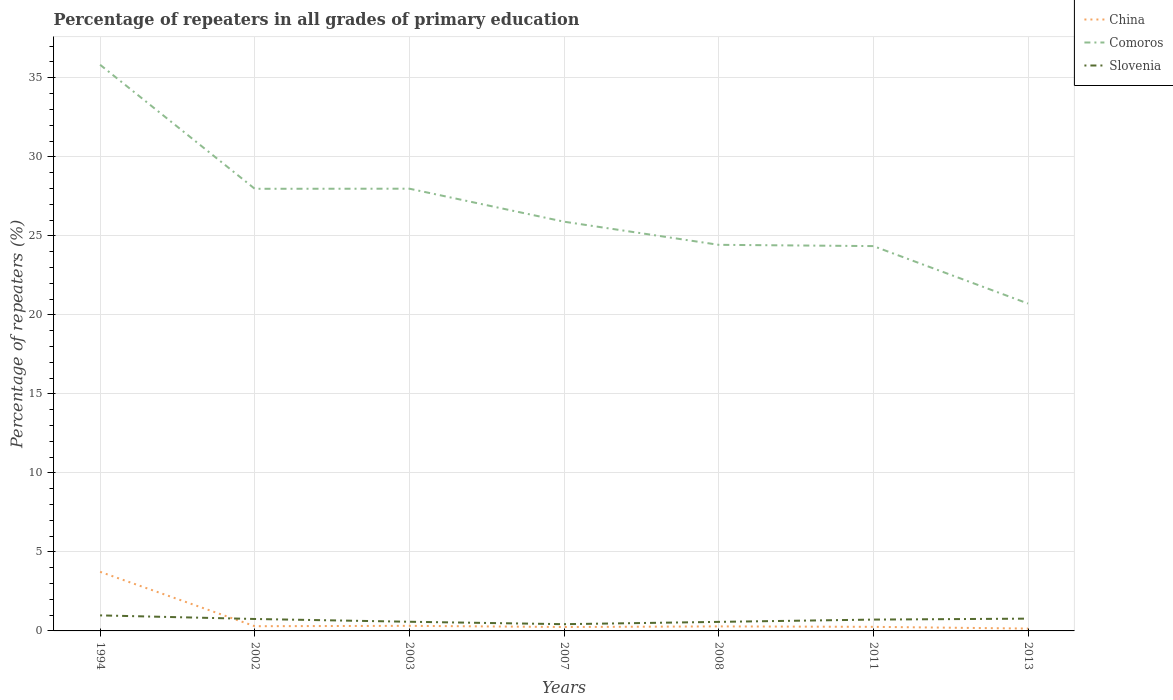How many different coloured lines are there?
Your answer should be compact. 3. Across all years, what is the maximum percentage of repeaters in Slovenia?
Ensure brevity in your answer.  0.43. What is the total percentage of repeaters in Slovenia in the graph?
Provide a short and direct response. 0.4. What is the difference between the highest and the second highest percentage of repeaters in Comoros?
Your answer should be very brief. 15.11. What is the difference between the highest and the lowest percentage of repeaters in China?
Keep it short and to the point. 1. Is the percentage of repeaters in Slovenia strictly greater than the percentage of repeaters in Comoros over the years?
Your answer should be very brief. Yes. How many lines are there?
Your response must be concise. 3. How many years are there in the graph?
Provide a short and direct response. 7. What is the difference between two consecutive major ticks on the Y-axis?
Offer a terse response. 5. Does the graph contain any zero values?
Provide a succinct answer. No. Does the graph contain grids?
Make the answer very short. Yes. How many legend labels are there?
Offer a very short reply. 3. What is the title of the graph?
Provide a succinct answer. Percentage of repeaters in all grades of primary education. What is the label or title of the Y-axis?
Offer a terse response. Percentage of repeaters (%). What is the Percentage of repeaters (%) in China in 1994?
Make the answer very short. 3.74. What is the Percentage of repeaters (%) in Comoros in 1994?
Ensure brevity in your answer.  35.82. What is the Percentage of repeaters (%) of Slovenia in 1994?
Keep it short and to the point. 0.98. What is the Percentage of repeaters (%) in China in 2002?
Provide a succinct answer. 0.3. What is the Percentage of repeaters (%) in Comoros in 2002?
Your answer should be compact. 27.98. What is the Percentage of repeaters (%) of Slovenia in 2002?
Provide a succinct answer. 0.76. What is the Percentage of repeaters (%) in China in 2003?
Make the answer very short. 0.32. What is the Percentage of repeaters (%) of Comoros in 2003?
Provide a short and direct response. 27.98. What is the Percentage of repeaters (%) in Slovenia in 2003?
Offer a terse response. 0.58. What is the Percentage of repeaters (%) of China in 2007?
Your answer should be very brief. 0.25. What is the Percentage of repeaters (%) of Comoros in 2007?
Your answer should be compact. 25.9. What is the Percentage of repeaters (%) in Slovenia in 2007?
Make the answer very short. 0.43. What is the Percentage of repeaters (%) of China in 2008?
Provide a succinct answer. 0.29. What is the Percentage of repeaters (%) in Comoros in 2008?
Offer a terse response. 24.43. What is the Percentage of repeaters (%) in Slovenia in 2008?
Your answer should be very brief. 0.57. What is the Percentage of repeaters (%) in China in 2011?
Ensure brevity in your answer.  0.26. What is the Percentage of repeaters (%) of Comoros in 2011?
Provide a succinct answer. 24.35. What is the Percentage of repeaters (%) of Slovenia in 2011?
Give a very brief answer. 0.72. What is the Percentage of repeaters (%) of China in 2013?
Ensure brevity in your answer.  0.15. What is the Percentage of repeaters (%) in Comoros in 2013?
Provide a succinct answer. 20.72. What is the Percentage of repeaters (%) of Slovenia in 2013?
Ensure brevity in your answer.  0.78. Across all years, what is the maximum Percentage of repeaters (%) in China?
Provide a succinct answer. 3.74. Across all years, what is the maximum Percentage of repeaters (%) in Comoros?
Offer a very short reply. 35.82. Across all years, what is the maximum Percentage of repeaters (%) of Slovenia?
Give a very brief answer. 0.98. Across all years, what is the minimum Percentage of repeaters (%) of China?
Offer a terse response. 0.15. Across all years, what is the minimum Percentage of repeaters (%) in Comoros?
Offer a very short reply. 20.72. Across all years, what is the minimum Percentage of repeaters (%) in Slovenia?
Your answer should be compact. 0.43. What is the total Percentage of repeaters (%) of China in the graph?
Your answer should be very brief. 5.3. What is the total Percentage of repeaters (%) in Comoros in the graph?
Your response must be concise. 187.18. What is the total Percentage of repeaters (%) of Slovenia in the graph?
Offer a very short reply. 4.81. What is the difference between the Percentage of repeaters (%) in China in 1994 and that in 2002?
Ensure brevity in your answer.  3.44. What is the difference between the Percentage of repeaters (%) in Comoros in 1994 and that in 2002?
Make the answer very short. 7.85. What is the difference between the Percentage of repeaters (%) in Slovenia in 1994 and that in 2002?
Keep it short and to the point. 0.23. What is the difference between the Percentage of repeaters (%) of China in 1994 and that in 2003?
Give a very brief answer. 3.42. What is the difference between the Percentage of repeaters (%) of Comoros in 1994 and that in 2003?
Your answer should be very brief. 7.84. What is the difference between the Percentage of repeaters (%) in Slovenia in 1994 and that in 2003?
Make the answer very short. 0.4. What is the difference between the Percentage of repeaters (%) in China in 1994 and that in 2007?
Provide a short and direct response. 3.49. What is the difference between the Percentage of repeaters (%) in Comoros in 1994 and that in 2007?
Offer a terse response. 9.93. What is the difference between the Percentage of repeaters (%) in Slovenia in 1994 and that in 2007?
Your answer should be compact. 0.56. What is the difference between the Percentage of repeaters (%) of China in 1994 and that in 2008?
Make the answer very short. 3.45. What is the difference between the Percentage of repeaters (%) of Comoros in 1994 and that in 2008?
Make the answer very short. 11.39. What is the difference between the Percentage of repeaters (%) in Slovenia in 1994 and that in 2008?
Keep it short and to the point. 0.41. What is the difference between the Percentage of repeaters (%) in China in 1994 and that in 2011?
Your answer should be compact. 3.48. What is the difference between the Percentage of repeaters (%) in Comoros in 1994 and that in 2011?
Offer a very short reply. 11.47. What is the difference between the Percentage of repeaters (%) in Slovenia in 1994 and that in 2011?
Your response must be concise. 0.27. What is the difference between the Percentage of repeaters (%) in China in 1994 and that in 2013?
Make the answer very short. 3.59. What is the difference between the Percentage of repeaters (%) in Comoros in 1994 and that in 2013?
Offer a very short reply. 15.11. What is the difference between the Percentage of repeaters (%) of Slovenia in 1994 and that in 2013?
Keep it short and to the point. 0.21. What is the difference between the Percentage of repeaters (%) in China in 2002 and that in 2003?
Ensure brevity in your answer.  -0.02. What is the difference between the Percentage of repeaters (%) of Comoros in 2002 and that in 2003?
Your answer should be very brief. -0.01. What is the difference between the Percentage of repeaters (%) in Slovenia in 2002 and that in 2003?
Give a very brief answer. 0.18. What is the difference between the Percentage of repeaters (%) of China in 2002 and that in 2007?
Offer a terse response. 0.05. What is the difference between the Percentage of repeaters (%) of Comoros in 2002 and that in 2007?
Provide a short and direct response. 2.08. What is the difference between the Percentage of repeaters (%) of Slovenia in 2002 and that in 2007?
Give a very brief answer. 0.33. What is the difference between the Percentage of repeaters (%) of China in 2002 and that in 2008?
Your answer should be very brief. 0.01. What is the difference between the Percentage of repeaters (%) of Comoros in 2002 and that in 2008?
Ensure brevity in your answer.  3.55. What is the difference between the Percentage of repeaters (%) of Slovenia in 2002 and that in 2008?
Ensure brevity in your answer.  0.18. What is the difference between the Percentage of repeaters (%) of China in 2002 and that in 2011?
Make the answer very short. 0.04. What is the difference between the Percentage of repeaters (%) of Comoros in 2002 and that in 2011?
Provide a succinct answer. 3.63. What is the difference between the Percentage of repeaters (%) of Slovenia in 2002 and that in 2011?
Your answer should be very brief. 0.04. What is the difference between the Percentage of repeaters (%) in China in 2002 and that in 2013?
Provide a short and direct response. 0.15. What is the difference between the Percentage of repeaters (%) in Comoros in 2002 and that in 2013?
Provide a succinct answer. 7.26. What is the difference between the Percentage of repeaters (%) in Slovenia in 2002 and that in 2013?
Your answer should be very brief. -0.02. What is the difference between the Percentage of repeaters (%) of China in 2003 and that in 2007?
Provide a succinct answer. 0.08. What is the difference between the Percentage of repeaters (%) of Comoros in 2003 and that in 2007?
Ensure brevity in your answer.  2.09. What is the difference between the Percentage of repeaters (%) in Slovenia in 2003 and that in 2007?
Your response must be concise. 0.15. What is the difference between the Percentage of repeaters (%) in China in 2003 and that in 2008?
Make the answer very short. 0.04. What is the difference between the Percentage of repeaters (%) of Comoros in 2003 and that in 2008?
Offer a very short reply. 3.55. What is the difference between the Percentage of repeaters (%) of Slovenia in 2003 and that in 2008?
Your answer should be compact. 0.01. What is the difference between the Percentage of repeaters (%) of China in 2003 and that in 2011?
Ensure brevity in your answer.  0.06. What is the difference between the Percentage of repeaters (%) in Comoros in 2003 and that in 2011?
Offer a very short reply. 3.63. What is the difference between the Percentage of repeaters (%) in Slovenia in 2003 and that in 2011?
Keep it short and to the point. -0.14. What is the difference between the Percentage of repeaters (%) in China in 2003 and that in 2013?
Keep it short and to the point. 0.17. What is the difference between the Percentage of repeaters (%) of Comoros in 2003 and that in 2013?
Offer a very short reply. 7.27. What is the difference between the Percentage of repeaters (%) in Slovenia in 2003 and that in 2013?
Your answer should be very brief. -0.2. What is the difference between the Percentage of repeaters (%) in China in 2007 and that in 2008?
Your response must be concise. -0.04. What is the difference between the Percentage of repeaters (%) in Comoros in 2007 and that in 2008?
Keep it short and to the point. 1.46. What is the difference between the Percentage of repeaters (%) of Slovenia in 2007 and that in 2008?
Give a very brief answer. -0.15. What is the difference between the Percentage of repeaters (%) in China in 2007 and that in 2011?
Make the answer very short. -0.01. What is the difference between the Percentage of repeaters (%) in Comoros in 2007 and that in 2011?
Give a very brief answer. 1.54. What is the difference between the Percentage of repeaters (%) in Slovenia in 2007 and that in 2011?
Your response must be concise. -0.29. What is the difference between the Percentage of repeaters (%) in China in 2007 and that in 2013?
Your response must be concise. 0.1. What is the difference between the Percentage of repeaters (%) of Comoros in 2007 and that in 2013?
Your response must be concise. 5.18. What is the difference between the Percentage of repeaters (%) of Slovenia in 2007 and that in 2013?
Your answer should be compact. -0.35. What is the difference between the Percentage of repeaters (%) in China in 2008 and that in 2011?
Your response must be concise. 0.03. What is the difference between the Percentage of repeaters (%) of Comoros in 2008 and that in 2011?
Offer a very short reply. 0.08. What is the difference between the Percentage of repeaters (%) of Slovenia in 2008 and that in 2011?
Ensure brevity in your answer.  -0.14. What is the difference between the Percentage of repeaters (%) of China in 2008 and that in 2013?
Keep it short and to the point. 0.14. What is the difference between the Percentage of repeaters (%) of Comoros in 2008 and that in 2013?
Provide a short and direct response. 3.72. What is the difference between the Percentage of repeaters (%) in Slovenia in 2008 and that in 2013?
Give a very brief answer. -0.21. What is the difference between the Percentage of repeaters (%) of China in 2011 and that in 2013?
Your answer should be very brief. 0.11. What is the difference between the Percentage of repeaters (%) of Comoros in 2011 and that in 2013?
Give a very brief answer. 3.63. What is the difference between the Percentage of repeaters (%) of Slovenia in 2011 and that in 2013?
Your answer should be compact. -0.06. What is the difference between the Percentage of repeaters (%) in China in 1994 and the Percentage of repeaters (%) in Comoros in 2002?
Keep it short and to the point. -24.24. What is the difference between the Percentage of repeaters (%) in China in 1994 and the Percentage of repeaters (%) in Slovenia in 2002?
Offer a very short reply. 2.98. What is the difference between the Percentage of repeaters (%) in Comoros in 1994 and the Percentage of repeaters (%) in Slovenia in 2002?
Your response must be concise. 35.07. What is the difference between the Percentage of repeaters (%) in China in 1994 and the Percentage of repeaters (%) in Comoros in 2003?
Give a very brief answer. -24.24. What is the difference between the Percentage of repeaters (%) in China in 1994 and the Percentage of repeaters (%) in Slovenia in 2003?
Provide a short and direct response. 3.16. What is the difference between the Percentage of repeaters (%) in Comoros in 1994 and the Percentage of repeaters (%) in Slovenia in 2003?
Offer a very short reply. 35.24. What is the difference between the Percentage of repeaters (%) of China in 1994 and the Percentage of repeaters (%) of Comoros in 2007?
Keep it short and to the point. -22.16. What is the difference between the Percentage of repeaters (%) of China in 1994 and the Percentage of repeaters (%) of Slovenia in 2007?
Ensure brevity in your answer.  3.31. What is the difference between the Percentage of repeaters (%) of Comoros in 1994 and the Percentage of repeaters (%) of Slovenia in 2007?
Ensure brevity in your answer.  35.4. What is the difference between the Percentage of repeaters (%) in China in 1994 and the Percentage of repeaters (%) in Comoros in 2008?
Offer a terse response. -20.69. What is the difference between the Percentage of repeaters (%) in China in 1994 and the Percentage of repeaters (%) in Slovenia in 2008?
Your answer should be compact. 3.17. What is the difference between the Percentage of repeaters (%) of Comoros in 1994 and the Percentage of repeaters (%) of Slovenia in 2008?
Provide a short and direct response. 35.25. What is the difference between the Percentage of repeaters (%) in China in 1994 and the Percentage of repeaters (%) in Comoros in 2011?
Give a very brief answer. -20.61. What is the difference between the Percentage of repeaters (%) in China in 1994 and the Percentage of repeaters (%) in Slovenia in 2011?
Your response must be concise. 3.02. What is the difference between the Percentage of repeaters (%) in Comoros in 1994 and the Percentage of repeaters (%) in Slovenia in 2011?
Ensure brevity in your answer.  35.11. What is the difference between the Percentage of repeaters (%) of China in 1994 and the Percentage of repeaters (%) of Comoros in 2013?
Keep it short and to the point. -16.98. What is the difference between the Percentage of repeaters (%) of China in 1994 and the Percentage of repeaters (%) of Slovenia in 2013?
Give a very brief answer. 2.96. What is the difference between the Percentage of repeaters (%) of Comoros in 1994 and the Percentage of repeaters (%) of Slovenia in 2013?
Give a very brief answer. 35.05. What is the difference between the Percentage of repeaters (%) in China in 2002 and the Percentage of repeaters (%) in Comoros in 2003?
Keep it short and to the point. -27.69. What is the difference between the Percentage of repeaters (%) of China in 2002 and the Percentage of repeaters (%) of Slovenia in 2003?
Offer a terse response. -0.28. What is the difference between the Percentage of repeaters (%) in Comoros in 2002 and the Percentage of repeaters (%) in Slovenia in 2003?
Offer a terse response. 27.4. What is the difference between the Percentage of repeaters (%) of China in 2002 and the Percentage of repeaters (%) of Comoros in 2007?
Your response must be concise. -25.6. What is the difference between the Percentage of repeaters (%) in China in 2002 and the Percentage of repeaters (%) in Slovenia in 2007?
Offer a very short reply. -0.13. What is the difference between the Percentage of repeaters (%) in Comoros in 2002 and the Percentage of repeaters (%) in Slovenia in 2007?
Ensure brevity in your answer.  27.55. What is the difference between the Percentage of repeaters (%) of China in 2002 and the Percentage of repeaters (%) of Comoros in 2008?
Give a very brief answer. -24.13. What is the difference between the Percentage of repeaters (%) of China in 2002 and the Percentage of repeaters (%) of Slovenia in 2008?
Your response must be concise. -0.27. What is the difference between the Percentage of repeaters (%) of Comoros in 2002 and the Percentage of repeaters (%) of Slovenia in 2008?
Ensure brevity in your answer.  27.41. What is the difference between the Percentage of repeaters (%) of China in 2002 and the Percentage of repeaters (%) of Comoros in 2011?
Ensure brevity in your answer.  -24.05. What is the difference between the Percentage of repeaters (%) in China in 2002 and the Percentage of repeaters (%) in Slovenia in 2011?
Give a very brief answer. -0.42. What is the difference between the Percentage of repeaters (%) in Comoros in 2002 and the Percentage of repeaters (%) in Slovenia in 2011?
Provide a short and direct response. 27.26. What is the difference between the Percentage of repeaters (%) of China in 2002 and the Percentage of repeaters (%) of Comoros in 2013?
Give a very brief answer. -20.42. What is the difference between the Percentage of repeaters (%) of China in 2002 and the Percentage of repeaters (%) of Slovenia in 2013?
Provide a succinct answer. -0.48. What is the difference between the Percentage of repeaters (%) in Comoros in 2002 and the Percentage of repeaters (%) in Slovenia in 2013?
Make the answer very short. 27.2. What is the difference between the Percentage of repeaters (%) of China in 2003 and the Percentage of repeaters (%) of Comoros in 2007?
Make the answer very short. -25.57. What is the difference between the Percentage of repeaters (%) in China in 2003 and the Percentage of repeaters (%) in Slovenia in 2007?
Give a very brief answer. -0.1. What is the difference between the Percentage of repeaters (%) of Comoros in 2003 and the Percentage of repeaters (%) of Slovenia in 2007?
Ensure brevity in your answer.  27.56. What is the difference between the Percentage of repeaters (%) of China in 2003 and the Percentage of repeaters (%) of Comoros in 2008?
Make the answer very short. -24.11. What is the difference between the Percentage of repeaters (%) of China in 2003 and the Percentage of repeaters (%) of Slovenia in 2008?
Provide a short and direct response. -0.25. What is the difference between the Percentage of repeaters (%) in Comoros in 2003 and the Percentage of repeaters (%) in Slovenia in 2008?
Your response must be concise. 27.41. What is the difference between the Percentage of repeaters (%) of China in 2003 and the Percentage of repeaters (%) of Comoros in 2011?
Your answer should be very brief. -24.03. What is the difference between the Percentage of repeaters (%) in China in 2003 and the Percentage of repeaters (%) in Slovenia in 2011?
Offer a very short reply. -0.39. What is the difference between the Percentage of repeaters (%) in Comoros in 2003 and the Percentage of repeaters (%) in Slovenia in 2011?
Keep it short and to the point. 27.27. What is the difference between the Percentage of repeaters (%) of China in 2003 and the Percentage of repeaters (%) of Comoros in 2013?
Provide a succinct answer. -20.39. What is the difference between the Percentage of repeaters (%) of China in 2003 and the Percentage of repeaters (%) of Slovenia in 2013?
Keep it short and to the point. -0.46. What is the difference between the Percentage of repeaters (%) in Comoros in 2003 and the Percentage of repeaters (%) in Slovenia in 2013?
Keep it short and to the point. 27.21. What is the difference between the Percentage of repeaters (%) of China in 2007 and the Percentage of repeaters (%) of Comoros in 2008?
Offer a very short reply. -24.18. What is the difference between the Percentage of repeaters (%) of China in 2007 and the Percentage of repeaters (%) of Slovenia in 2008?
Provide a succinct answer. -0.33. What is the difference between the Percentage of repeaters (%) of Comoros in 2007 and the Percentage of repeaters (%) of Slovenia in 2008?
Give a very brief answer. 25.32. What is the difference between the Percentage of repeaters (%) in China in 2007 and the Percentage of repeaters (%) in Comoros in 2011?
Provide a succinct answer. -24.1. What is the difference between the Percentage of repeaters (%) in China in 2007 and the Percentage of repeaters (%) in Slovenia in 2011?
Your answer should be compact. -0.47. What is the difference between the Percentage of repeaters (%) of Comoros in 2007 and the Percentage of repeaters (%) of Slovenia in 2011?
Give a very brief answer. 25.18. What is the difference between the Percentage of repeaters (%) in China in 2007 and the Percentage of repeaters (%) in Comoros in 2013?
Give a very brief answer. -20.47. What is the difference between the Percentage of repeaters (%) of China in 2007 and the Percentage of repeaters (%) of Slovenia in 2013?
Provide a short and direct response. -0.53. What is the difference between the Percentage of repeaters (%) in Comoros in 2007 and the Percentage of repeaters (%) in Slovenia in 2013?
Provide a succinct answer. 25.12. What is the difference between the Percentage of repeaters (%) of China in 2008 and the Percentage of repeaters (%) of Comoros in 2011?
Provide a short and direct response. -24.06. What is the difference between the Percentage of repeaters (%) of China in 2008 and the Percentage of repeaters (%) of Slovenia in 2011?
Ensure brevity in your answer.  -0.43. What is the difference between the Percentage of repeaters (%) of Comoros in 2008 and the Percentage of repeaters (%) of Slovenia in 2011?
Offer a terse response. 23.71. What is the difference between the Percentage of repeaters (%) of China in 2008 and the Percentage of repeaters (%) of Comoros in 2013?
Your answer should be very brief. -20.43. What is the difference between the Percentage of repeaters (%) in China in 2008 and the Percentage of repeaters (%) in Slovenia in 2013?
Your response must be concise. -0.49. What is the difference between the Percentage of repeaters (%) in Comoros in 2008 and the Percentage of repeaters (%) in Slovenia in 2013?
Make the answer very short. 23.65. What is the difference between the Percentage of repeaters (%) of China in 2011 and the Percentage of repeaters (%) of Comoros in 2013?
Offer a terse response. -20.46. What is the difference between the Percentage of repeaters (%) in China in 2011 and the Percentage of repeaters (%) in Slovenia in 2013?
Keep it short and to the point. -0.52. What is the difference between the Percentage of repeaters (%) of Comoros in 2011 and the Percentage of repeaters (%) of Slovenia in 2013?
Make the answer very short. 23.57. What is the average Percentage of repeaters (%) in China per year?
Your answer should be very brief. 0.76. What is the average Percentage of repeaters (%) in Comoros per year?
Provide a succinct answer. 26.74. What is the average Percentage of repeaters (%) in Slovenia per year?
Your answer should be compact. 0.69. In the year 1994, what is the difference between the Percentage of repeaters (%) of China and Percentage of repeaters (%) of Comoros?
Make the answer very short. -32.09. In the year 1994, what is the difference between the Percentage of repeaters (%) of China and Percentage of repeaters (%) of Slovenia?
Your answer should be compact. 2.76. In the year 1994, what is the difference between the Percentage of repeaters (%) of Comoros and Percentage of repeaters (%) of Slovenia?
Offer a terse response. 34.84. In the year 2002, what is the difference between the Percentage of repeaters (%) in China and Percentage of repeaters (%) in Comoros?
Your answer should be compact. -27.68. In the year 2002, what is the difference between the Percentage of repeaters (%) in China and Percentage of repeaters (%) in Slovenia?
Your response must be concise. -0.46. In the year 2002, what is the difference between the Percentage of repeaters (%) of Comoros and Percentage of repeaters (%) of Slovenia?
Your response must be concise. 27.22. In the year 2003, what is the difference between the Percentage of repeaters (%) of China and Percentage of repeaters (%) of Comoros?
Offer a terse response. -27.66. In the year 2003, what is the difference between the Percentage of repeaters (%) of China and Percentage of repeaters (%) of Slovenia?
Offer a very short reply. -0.26. In the year 2003, what is the difference between the Percentage of repeaters (%) in Comoros and Percentage of repeaters (%) in Slovenia?
Give a very brief answer. 27.4. In the year 2007, what is the difference between the Percentage of repeaters (%) in China and Percentage of repeaters (%) in Comoros?
Give a very brief answer. -25.65. In the year 2007, what is the difference between the Percentage of repeaters (%) of China and Percentage of repeaters (%) of Slovenia?
Give a very brief answer. -0.18. In the year 2007, what is the difference between the Percentage of repeaters (%) of Comoros and Percentage of repeaters (%) of Slovenia?
Offer a very short reply. 25.47. In the year 2008, what is the difference between the Percentage of repeaters (%) of China and Percentage of repeaters (%) of Comoros?
Your response must be concise. -24.14. In the year 2008, what is the difference between the Percentage of repeaters (%) of China and Percentage of repeaters (%) of Slovenia?
Your answer should be very brief. -0.29. In the year 2008, what is the difference between the Percentage of repeaters (%) of Comoros and Percentage of repeaters (%) of Slovenia?
Make the answer very short. 23.86. In the year 2011, what is the difference between the Percentage of repeaters (%) in China and Percentage of repeaters (%) in Comoros?
Provide a short and direct response. -24.09. In the year 2011, what is the difference between the Percentage of repeaters (%) of China and Percentage of repeaters (%) of Slovenia?
Make the answer very short. -0.46. In the year 2011, what is the difference between the Percentage of repeaters (%) in Comoros and Percentage of repeaters (%) in Slovenia?
Make the answer very short. 23.63. In the year 2013, what is the difference between the Percentage of repeaters (%) in China and Percentage of repeaters (%) in Comoros?
Give a very brief answer. -20.57. In the year 2013, what is the difference between the Percentage of repeaters (%) in China and Percentage of repeaters (%) in Slovenia?
Your response must be concise. -0.63. In the year 2013, what is the difference between the Percentage of repeaters (%) of Comoros and Percentage of repeaters (%) of Slovenia?
Offer a terse response. 19.94. What is the ratio of the Percentage of repeaters (%) in China in 1994 to that in 2002?
Keep it short and to the point. 12.56. What is the ratio of the Percentage of repeaters (%) in Comoros in 1994 to that in 2002?
Make the answer very short. 1.28. What is the ratio of the Percentage of repeaters (%) of Slovenia in 1994 to that in 2002?
Provide a short and direct response. 1.3. What is the ratio of the Percentage of repeaters (%) of China in 1994 to that in 2003?
Offer a very short reply. 11.6. What is the ratio of the Percentage of repeaters (%) of Comoros in 1994 to that in 2003?
Make the answer very short. 1.28. What is the ratio of the Percentage of repeaters (%) in Slovenia in 1994 to that in 2003?
Offer a terse response. 1.7. What is the ratio of the Percentage of repeaters (%) of China in 1994 to that in 2007?
Your response must be concise. 15.16. What is the ratio of the Percentage of repeaters (%) in Comoros in 1994 to that in 2007?
Offer a terse response. 1.38. What is the ratio of the Percentage of repeaters (%) in Slovenia in 1994 to that in 2007?
Your response must be concise. 2.31. What is the ratio of the Percentage of repeaters (%) in China in 1994 to that in 2008?
Your answer should be very brief. 13.04. What is the ratio of the Percentage of repeaters (%) of Comoros in 1994 to that in 2008?
Offer a terse response. 1.47. What is the ratio of the Percentage of repeaters (%) in Slovenia in 1994 to that in 2008?
Provide a short and direct response. 1.72. What is the ratio of the Percentage of repeaters (%) in China in 1994 to that in 2011?
Offer a terse response. 14.48. What is the ratio of the Percentage of repeaters (%) of Comoros in 1994 to that in 2011?
Your answer should be very brief. 1.47. What is the ratio of the Percentage of repeaters (%) of Slovenia in 1994 to that in 2011?
Offer a very short reply. 1.37. What is the ratio of the Percentage of repeaters (%) in China in 1994 to that in 2013?
Provide a short and direct response. 25.2. What is the ratio of the Percentage of repeaters (%) in Comoros in 1994 to that in 2013?
Your response must be concise. 1.73. What is the ratio of the Percentage of repeaters (%) of Slovenia in 1994 to that in 2013?
Keep it short and to the point. 1.26. What is the ratio of the Percentage of repeaters (%) of China in 2002 to that in 2003?
Offer a terse response. 0.92. What is the ratio of the Percentage of repeaters (%) in Slovenia in 2002 to that in 2003?
Provide a short and direct response. 1.3. What is the ratio of the Percentage of repeaters (%) in China in 2002 to that in 2007?
Provide a succinct answer. 1.21. What is the ratio of the Percentage of repeaters (%) in Comoros in 2002 to that in 2007?
Offer a terse response. 1.08. What is the ratio of the Percentage of repeaters (%) of Slovenia in 2002 to that in 2007?
Provide a succinct answer. 1.77. What is the ratio of the Percentage of repeaters (%) in China in 2002 to that in 2008?
Your answer should be compact. 1.04. What is the ratio of the Percentage of repeaters (%) in Comoros in 2002 to that in 2008?
Make the answer very short. 1.15. What is the ratio of the Percentage of repeaters (%) of Slovenia in 2002 to that in 2008?
Keep it short and to the point. 1.32. What is the ratio of the Percentage of repeaters (%) of China in 2002 to that in 2011?
Provide a succinct answer. 1.15. What is the ratio of the Percentage of repeaters (%) in Comoros in 2002 to that in 2011?
Provide a succinct answer. 1.15. What is the ratio of the Percentage of repeaters (%) of Slovenia in 2002 to that in 2011?
Ensure brevity in your answer.  1.05. What is the ratio of the Percentage of repeaters (%) in China in 2002 to that in 2013?
Provide a succinct answer. 2.01. What is the ratio of the Percentage of repeaters (%) of Comoros in 2002 to that in 2013?
Offer a terse response. 1.35. What is the ratio of the Percentage of repeaters (%) in Slovenia in 2002 to that in 2013?
Your answer should be compact. 0.97. What is the ratio of the Percentage of repeaters (%) in China in 2003 to that in 2007?
Your response must be concise. 1.31. What is the ratio of the Percentage of repeaters (%) in Comoros in 2003 to that in 2007?
Your response must be concise. 1.08. What is the ratio of the Percentage of repeaters (%) in Slovenia in 2003 to that in 2007?
Offer a very short reply. 1.36. What is the ratio of the Percentage of repeaters (%) in China in 2003 to that in 2008?
Offer a terse response. 1.12. What is the ratio of the Percentage of repeaters (%) of Comoros in 2003 to that in 2008?
Provide a short and direct response. 1.15. What is the ratio of the Percentage of repeaters (%) in Slovenia in 2003 to that in 2008?
Keep it short and to the point. 1.01. What is the ratio of the Percentage of repeaters (%) in China in 2003 to that in 2011?
Your answer should be compact. 1.25. What is the ratio of the Percentage of repeaters (%) in Comoros in 2003 to that in 2011?
Your response must be concise. 1.15. What is the ratio of the Percentage of repeaters (%) in Slovenia in 2003 to that in 2011?
Your answer should be compact. 0.81. What is the ratio of the Percentage of repeaters (%) in China in 2003 to that in 2013?
Offer a very short reply. 2.17. What is the ratio of the Percentage of repeaters (%) in Comoros in 2003 to that in 2013?
Provide a succinct answer. 1.35. What is the ratio of the Percentage of repeaters (%) in Slovenia in 2003 to that in 2013?
Ensure brevity in your answer.  0.75. What is the ratio of the Percentage of repeaters (%) in China in 2007 to that in 2008?
Ensure brevity in your answer.  0.86. What is the ratio of the Percentage of repeaters (%) of Comoros in 2007 to that in 2008?
Offer a terse response. 1.06. What is the ratio of the Percentage of repeaters (%) in Slovenia in 2007 to that in 2008?
Provide a short and direct response. 0.75. What is the ratio of the Percentage of repeaters (%) in China in 2007 to that in 2011?
Your response must be concise. 0.96. What is the ratio of the Percentage of repeaters (%) of Comoros in 2007 to that in 2011?
Give a very brief answer. 1.06. What is the ratio of the Percentage of repeaters (%) of Slovenia in 2007 to that in 2011?
Ensure brevity in your answer.  0.59. What is the ratio of the Percentage of repeaters (%) of China in 2007 to that in 2013?
Your response must be concise. 1.66. What is the ratio of the Percentage of repeaters (%) of Comoros in 2007 to that in 2013?
Make the answer very short. 1.25. What is the ratio of the Percentage of repeaters (%) in Slovenia in 2007 to that in 2013?
Provide a succinct answer. 0.55. What is the ratio of the Percentage of repeaters (%) of China in 2008 to that in 2011?
Make the answer very short. 1.11. What is the ratio of the Percentage of repeaters (%) in Comoros in 2008 to that in 2011?
Provide a short and direct response. 1. What is the ratio of the Percentage of repeaters (%) of Slovenia in 2008 to that in 2011?
Your response must be concise. 0.8. What is the ratio of the Percentage of repeaters (%) of China in 2008 to that in 2013?
Your response must be concise. 1.93. What is the ratio of the Percentage of repeaters (%) in Comoros in 2008 to that in 2013?
Keep it short and to the point. 1.18. What is the ratio of the Percentage of repeaters (%) of Slovenia in 2008 to that in 2013?
Ensure brevity in your answer.  0.74. What is the ratio of the Percentage of repeaters (%) in China in 2011 to that in 2013?
Ensure brevity in your answer.  1.74. What is the ratio of the Percentage of repeaters (%) in Comoros in 2011 to that in 2013?
Give a very brief answer. 1.18. What is the ratio of the Percentage of repeaters (%) in Slovenia in 2011 to that in 2013?
Provide a succinct answer. 0.92. What is the difference between the highest and the second highest Percentage of repeaters (%) of China?
Your response must be concise. 3.42. What is the difference between the highest and the second highest Percentage of repeaters (%) of Comoros?
Offer a very short reply. 7.84. What is the difference between the highest and the second highest Percentage of repeaters (%) in Slovenia?
Provide a succinct answer. 0.21. What is the difference between the highest and the lowest Percentage of repeaters (%) of China?
Provide a short and direct response. 3.59. What is the difference between the highest and the lowest Percentage of repeaters (%) in Comoros?
Offer a very short reply. 15.11. What is the difference between the highest and the lowest Percentage of repeaters (%) in Slovenia?
Offer a very short reply. 0.56. 